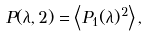Convert formula to latex. <formula><loc_0><loc_0><loc_500><loc_500>P ( \lambda , 2 ) = \left \langle P _ { 1 } ( \lambda ) ^ { 2 } \right \rangle ,</formula> 